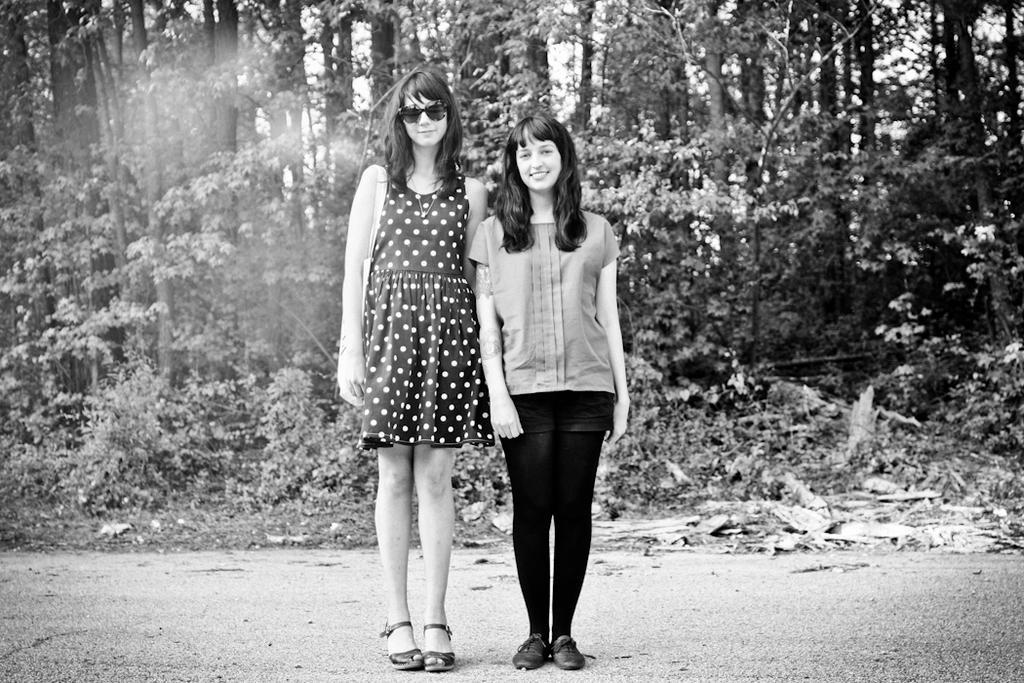Describe this image in one or two sentences. In the middle of the image two women are standing and smiling. Behind them there are some trees. 